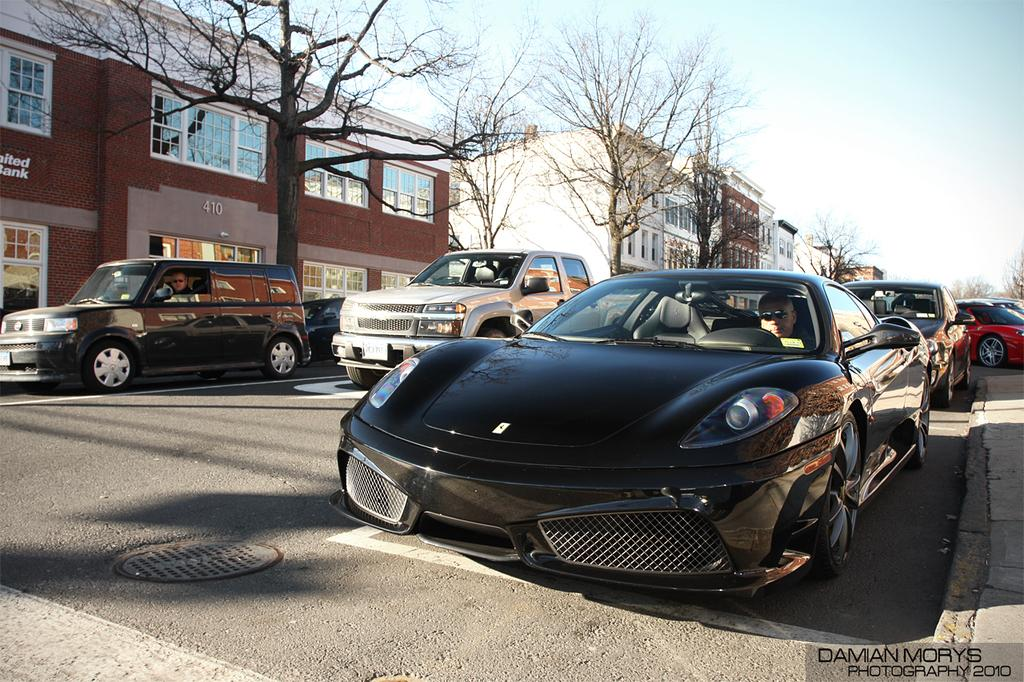What type of vehicles can be seen in the image? There are cars in the image. What structures are visible in the image? There are buildings in the image. What type of vegetation is present in the image? There are trees in the image. How would you describe the sky in the image? The sky is blue and cloudy in the image. Can you see any snakes slithering around the buildings in the image? There are no snakes present in the image. Is there a bomb visible in the image? There is no bomb present in the image. 